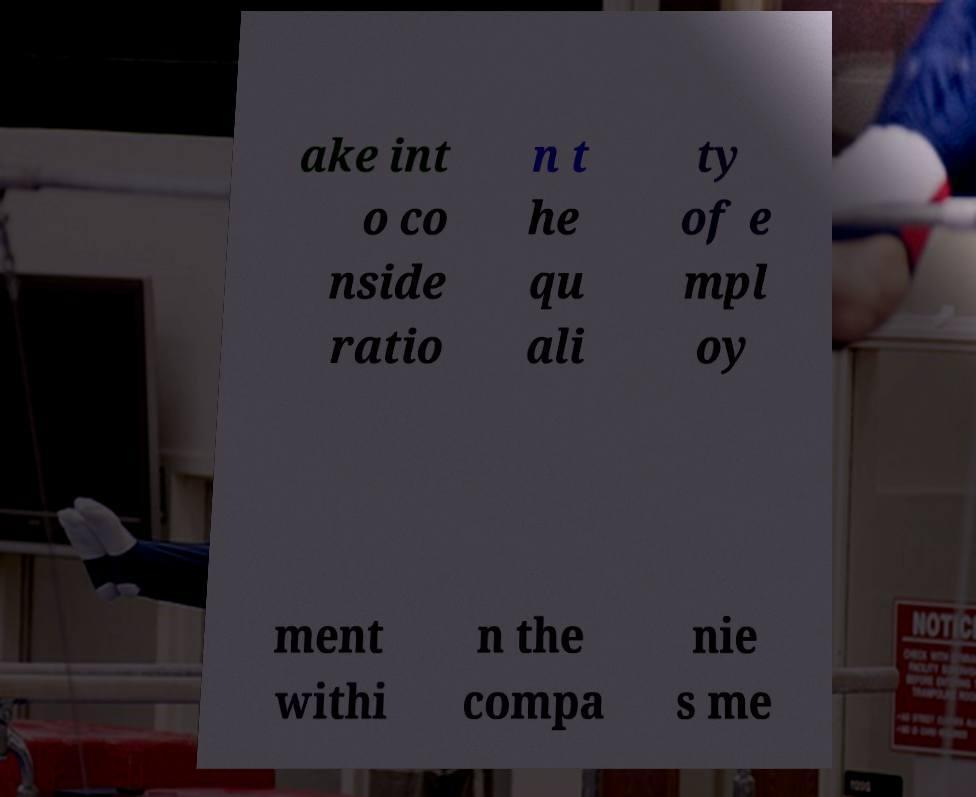Can you read and provide the text displayed in the image?This photo seems to have some interesting text. Can you extract and type it out for me? ake int o co nside ratio n t he qu ali ty of e mpl oy ment withi n the compa nie s me 